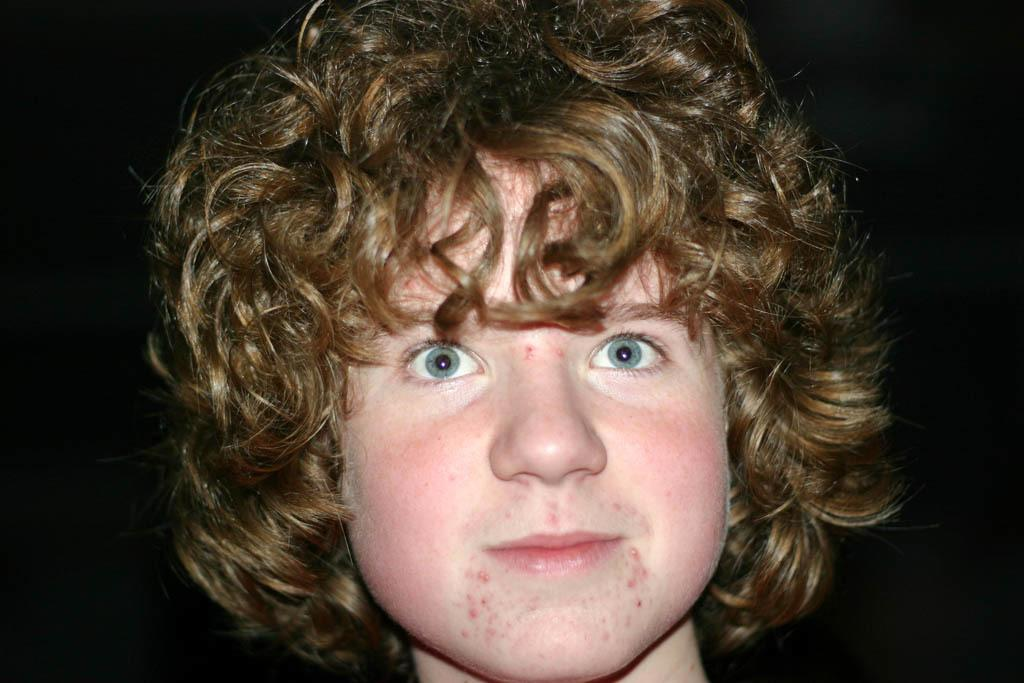What is the main subject of the image? There is a person in the image. Can you describe the person's appearance? The person has blue eyes, gold hair, and pink cheeks. What type of seat can be seen in the image? There is no seat present in the image; it features a person with blue eyes, gold hair, and pink cheeks. Is there a bridge visible in the image? There is no bridge present in the image. 